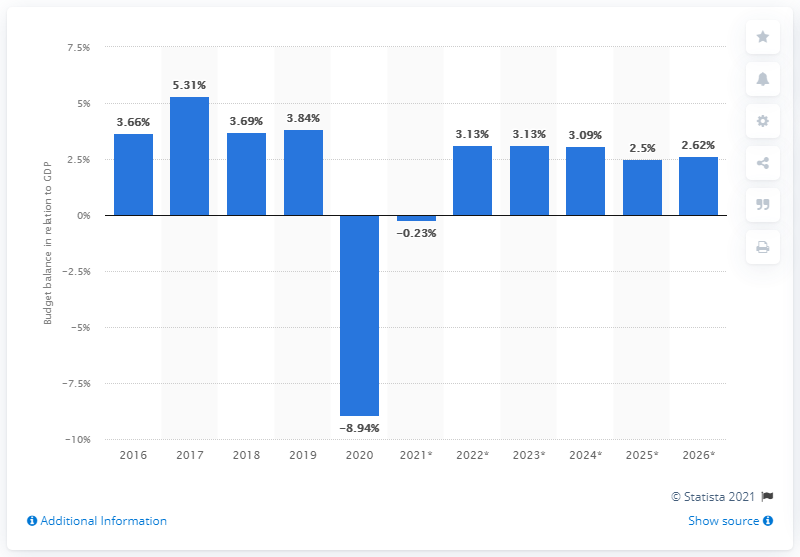Identify some key points in this picture. In 2020, Singapore's budget balance last related to GDP. 